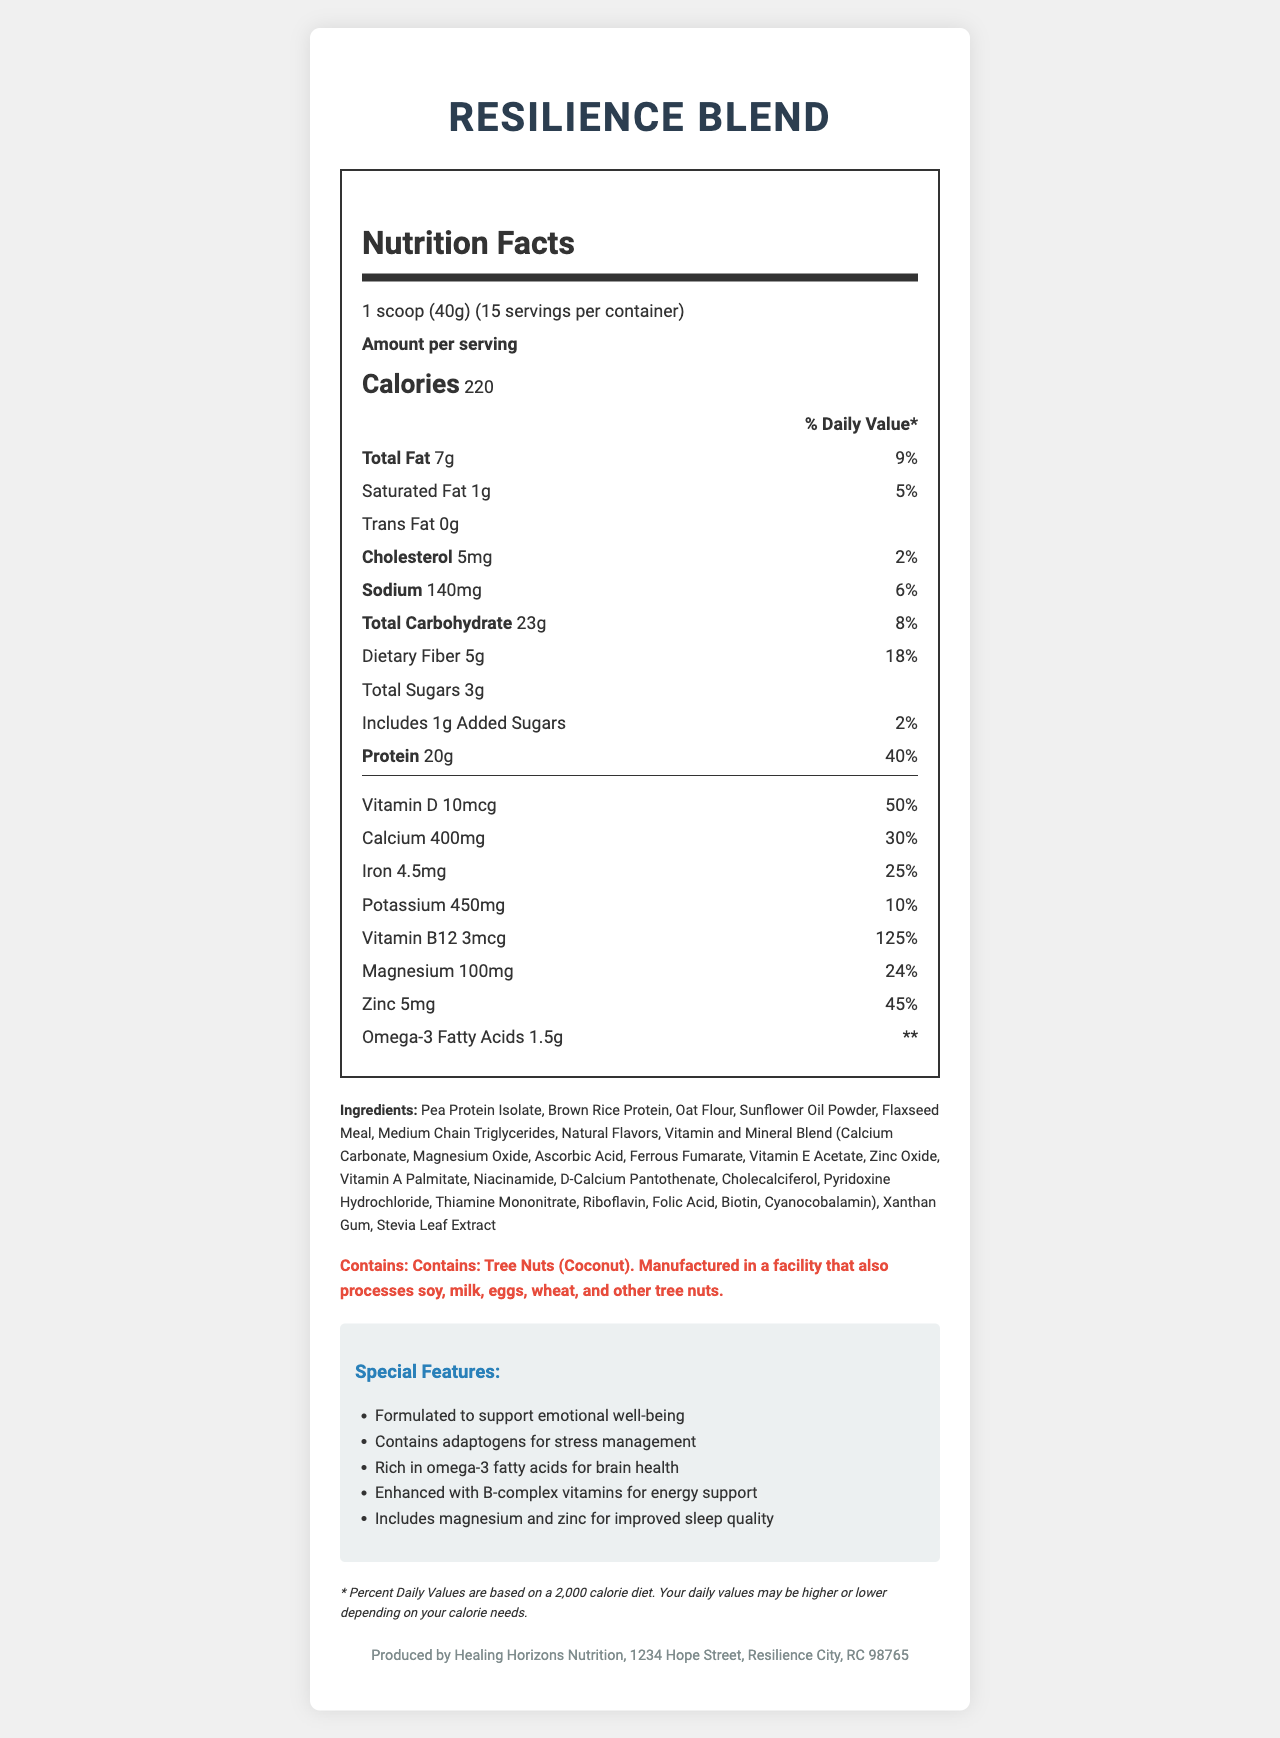what is the serving size for Resilience Blend? The document states that the serving size for Resilience Blend is 1 scoop (40g).
Answer: 1 scoop (40g) how much protein is in one serving of Resilience Blend? According to the document, one serving of Resilience Blend contains 20g of protein.
Answer: 20g what is the main vitamin that contributes to energy support? The special features section mentions that Resilience Blend is enhanced with B-complex vitamins for energy support, with Vitamin B12 providing 125% of the daily value.
Answer: Vitamin B12 what ingredient might cause allergies in some people? The allergen information indicates that the product contains tree nuts (coconut) and is manufactured in a facility that processes other common allergens.
Answer: Tree Nuts (Coconut) what is the daily value percentage of calcium in one serving? The daily value percentage of calcium as indicated in the vitamins and minerals section is 30%.
Answer: 30% how many calories are in one serving of Resilience Blend? The document states that each serving contains 220 calories.
Answer: 220 calories how many servings are there per container? The document specifies that there are 15 servings per container.
Answer: 15 servings what is the total amount of dietary fiber per serving? According to the nutrition facts section, one serving includes 5g of dietary fiber.
Answer: 5g does the product contain any trans fat? The nutrition facts label indicates that the amount of trans fat in the product is 0g.
Answer: No provide a brief summary of the document contents This summary covers the main ideas presented in the document, including the product's purpose, nutritional content, and special features.
Answer: The document describes the nutrition facts for a product called Resilience Blend, a meal replacement shake designed to support trauma survivors. It includes detailed information on serving size, calorie count, macronutrient and micronutrient content, ingredients, allergen information, and special features aimed at promoting emotional well-being, stress management, brain health, energy support, and improved sleep quality. can the exact flavor of Resilience Blend be determined from the document? The document lists "Natural Flavors" as an ingredient but does not specify the exact flavor of the product.
Answer: Cannot be determined 